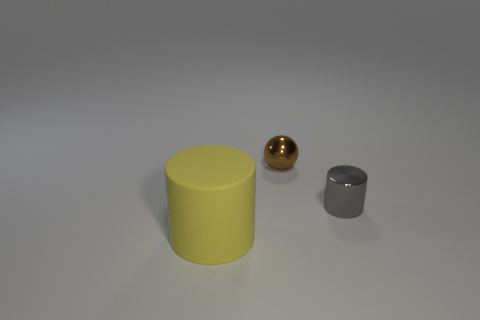Add 1 large yellow balls. How many objects exist? 4 Subtract all balls. How many objects are left? 2 Subtract 0 purple balls. How many objects are left? 3 Subtract all metallic cylinders. Subtract all spheres. How many objects are left? 1 Add 3 yellow matte cylinders. How many yellow matte cylinders are left? 4 Add 2 brown metallic things. How many brown metallic things exist? 3 